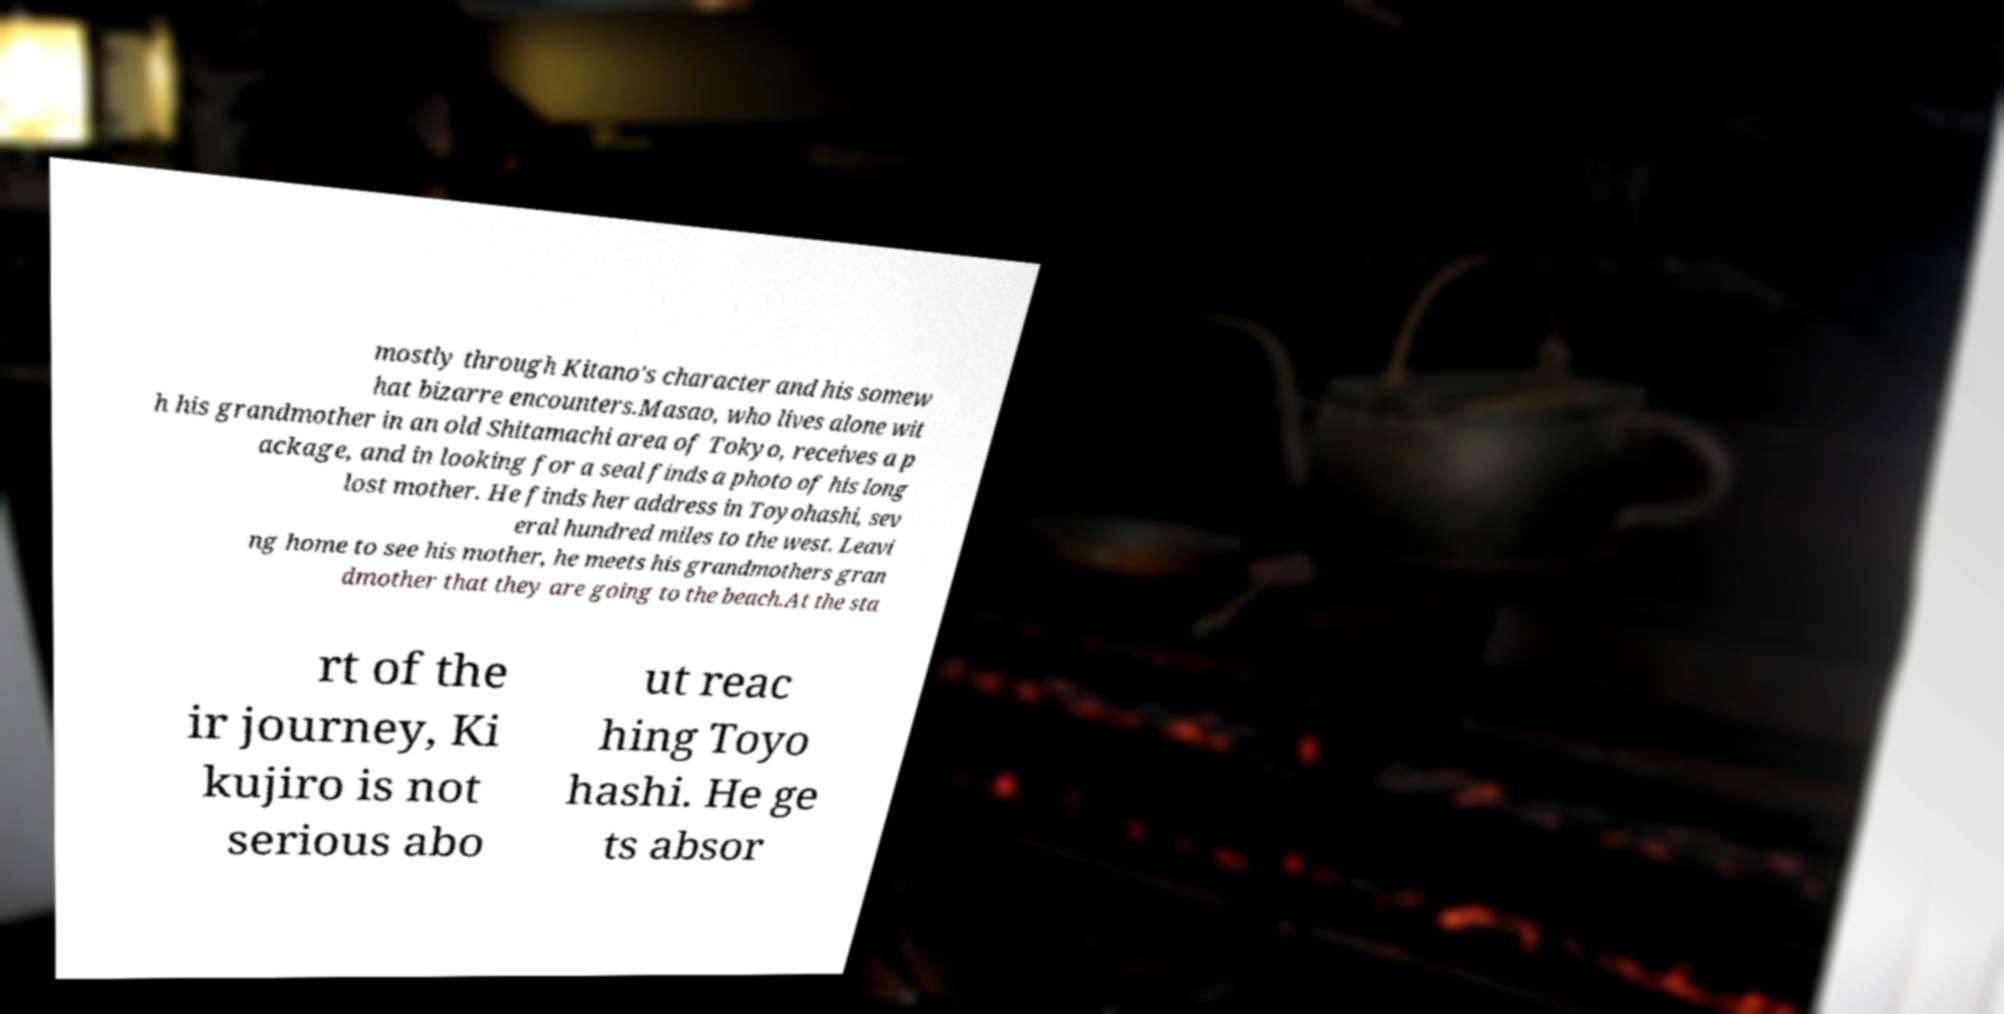Could you extract and type out the text from this image? mostly through Kitano's character and his somew hat bizarre encounters.Masao, who lives alone wit h his grandmother in an old Shitamachi area of Tokyo, receives a p ackage, and in looking for a seal finds a photo of his long lost mother. He finds her address in Toyohashi, sev eral hundred miles to the west. Leavi ng home to see his mother, he meets his grandmothers gran dmother that they are going to the beach.At the sta rt of the ir journey, Ki kujiro is not serious abo ut reac hing Toyo hashi. He ge ts absor 